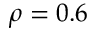Convert formula to latex. <formula><loc_0><loc_0><loc_500><loc_500>\rho = 0 . 6</formula> 